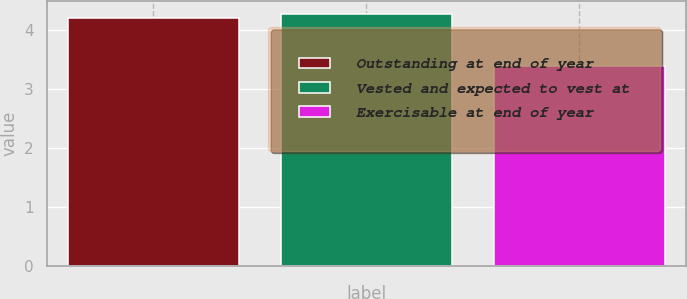Convert chart. <chart><loc_0><loc_0><loc_500><loc_500><bar_chart><fcel>Outstanding at end of year<fcel>Vested and expected to vest at<fcel>Exercisable at end of year<nl><fcel>4.2<fcel>4.28<fcel>3.4<nl></chart> 